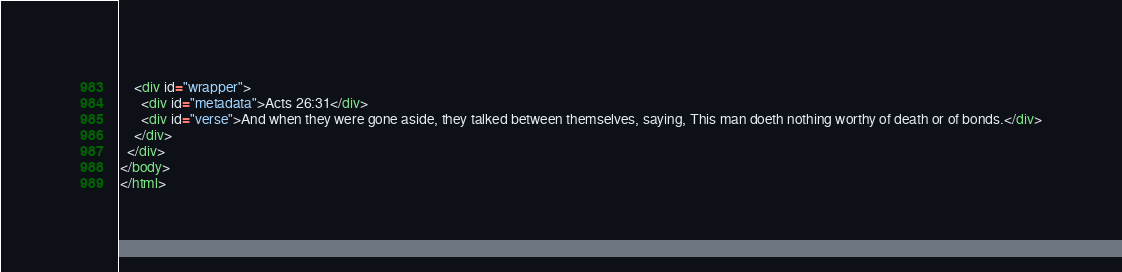<code> <loc_0><loc_0><loc_500><loc_500><_HTML_>    <div id="wrapper">
      <div id="metadata">Acts 26:31</div>
      <div id="verse">And when they were gone aside, they talked between themselves, saying, This man doeth nothing worthy of death or of bonds.</div>
    </div>
  </div>
</body>
</html></code> 